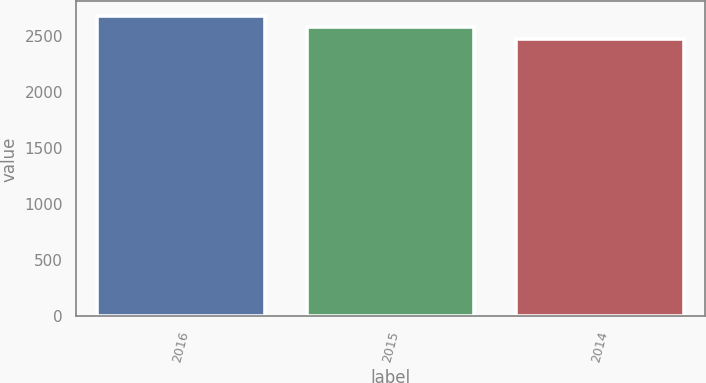Convert chart. <chart><loc_0><loc_0><loc_500><loc_500><bar_chart><fcel>2016<fcel>2015<fcel>2014<nl><fcel>2677.8<fcel>2581.6<fcel>2471.6<nl></chart> 